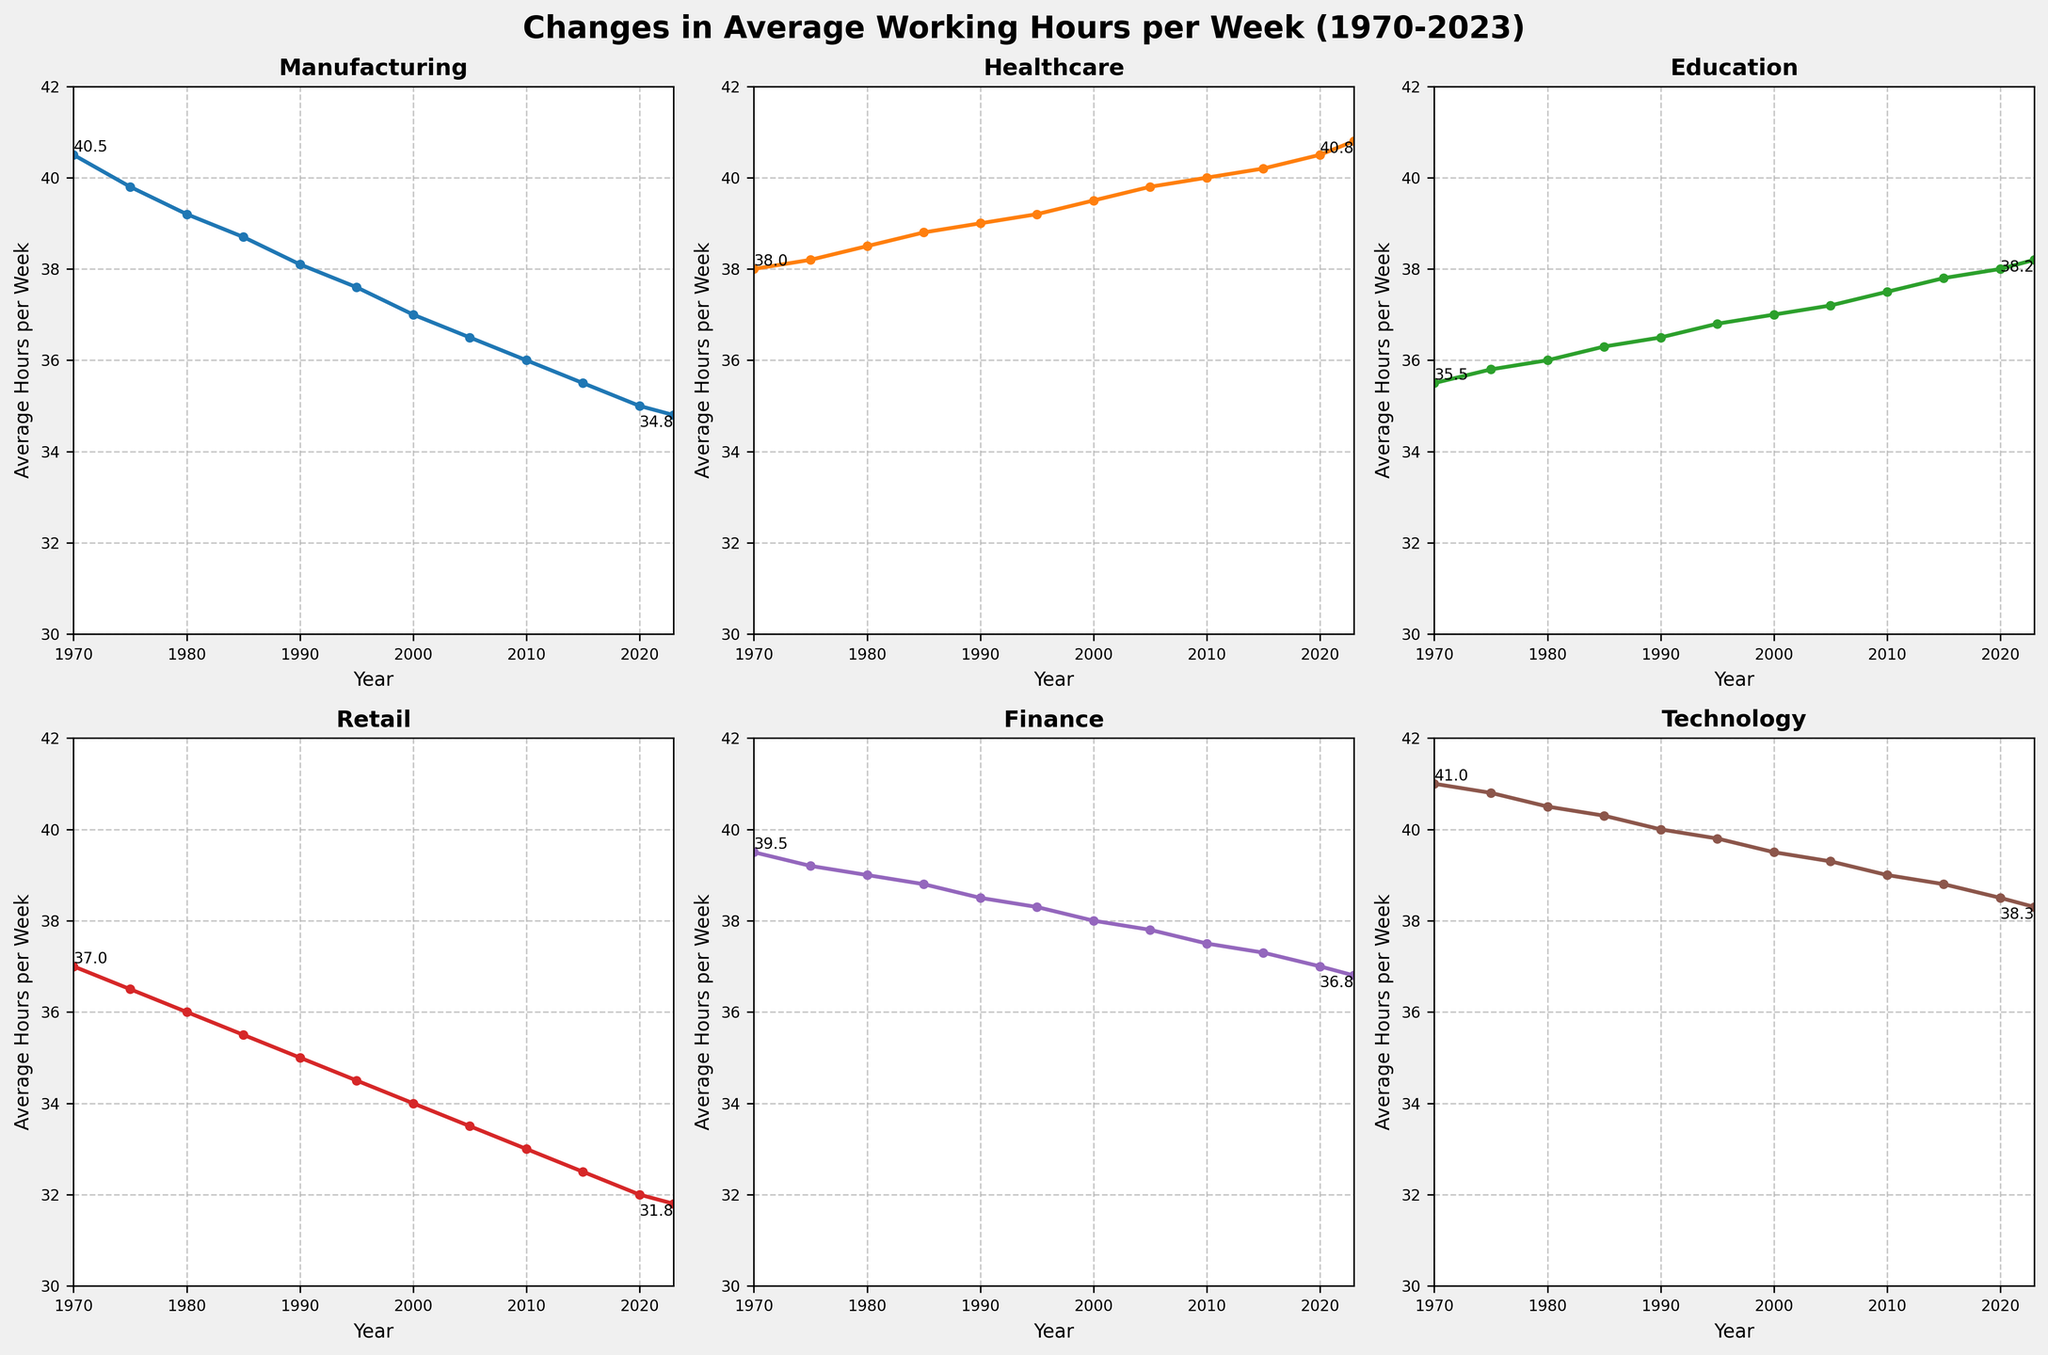What is the trend for average working hours in Manufacturing from 1970 to 2023? The line for Manufacturing shows a consistent decline from 40.5 hours in 1970 to 34.8 hours in 2023, indicating a downward trend.
Answer: Downward trend Which occupation had the highest average working hours in 2023? By examining the ending points of all lines in 2023, Healthcare has the highest value at 40.8 hours per week.
Answer: Healthcare How many occupations showed an increase in average working hours from 1970 to 2023? Comparing the start and end values for each occupation, only Healthcare and Education show an increase from 38.0 to 40.8 and 35.5 to 38.2, respectively.
Answer: 2 Which occupation exhibited the greatest decrease in average working hours between 1970 and 2023? Subtracting the values of 2023 from 1970 for each occupation, Manufacturing displayed the greatest decrease: 40.5 - 34.8 = 5.7 hours.
Answer: Manufacturing Between which years did Technology see the most significant drop in working hours? By comparing the differences between consecutive years for Technology, the largest drop is from 1980 (40.5) to 1985 (40.3), a decrease of 0.2 hours.
Answer: 1980-1985 Compare the average working hours of Finance and Technology in 1990. Which one was higher, and by how much? In 1990, Finance had 38.5 hours, and Technology had 40.0 hours. The difference is 40.0 - 38.5 = 1.5 hours, making Technology higher.
Answer: Technology, 1.5 hours What color is used to represent the Retail occupation and what does it signify? The Retail occupation is represented by a red line. This helps to visually differentiate it from the other occupations.
Answer: Red In which period did Healthcare surpass Finance in average working hours? Healthcare surpassed Finance between 1985 and 1990, as seen by the crossover of the lines.
Answer: 1985-1990 Calculate the average of the final values (2023) for all occupations. Sum the final values: Manufacturing (34.8) + Healthcare (40.8) + Education (38.2) + Retail (31.8) + Finance (36.8) + Technology (38.3) = 220.7. Divide by the number of occupations (6). Average = 220.7 / 6 = 36.78 hours.
Answer: 36.78 hours Which occupation had the least variation in average working hours over the entire period? By visually comparing the smoothness of the lines, Finance shows the least variation with values consistently around the mid-to-high 30s over the period.
Answer: Finance 